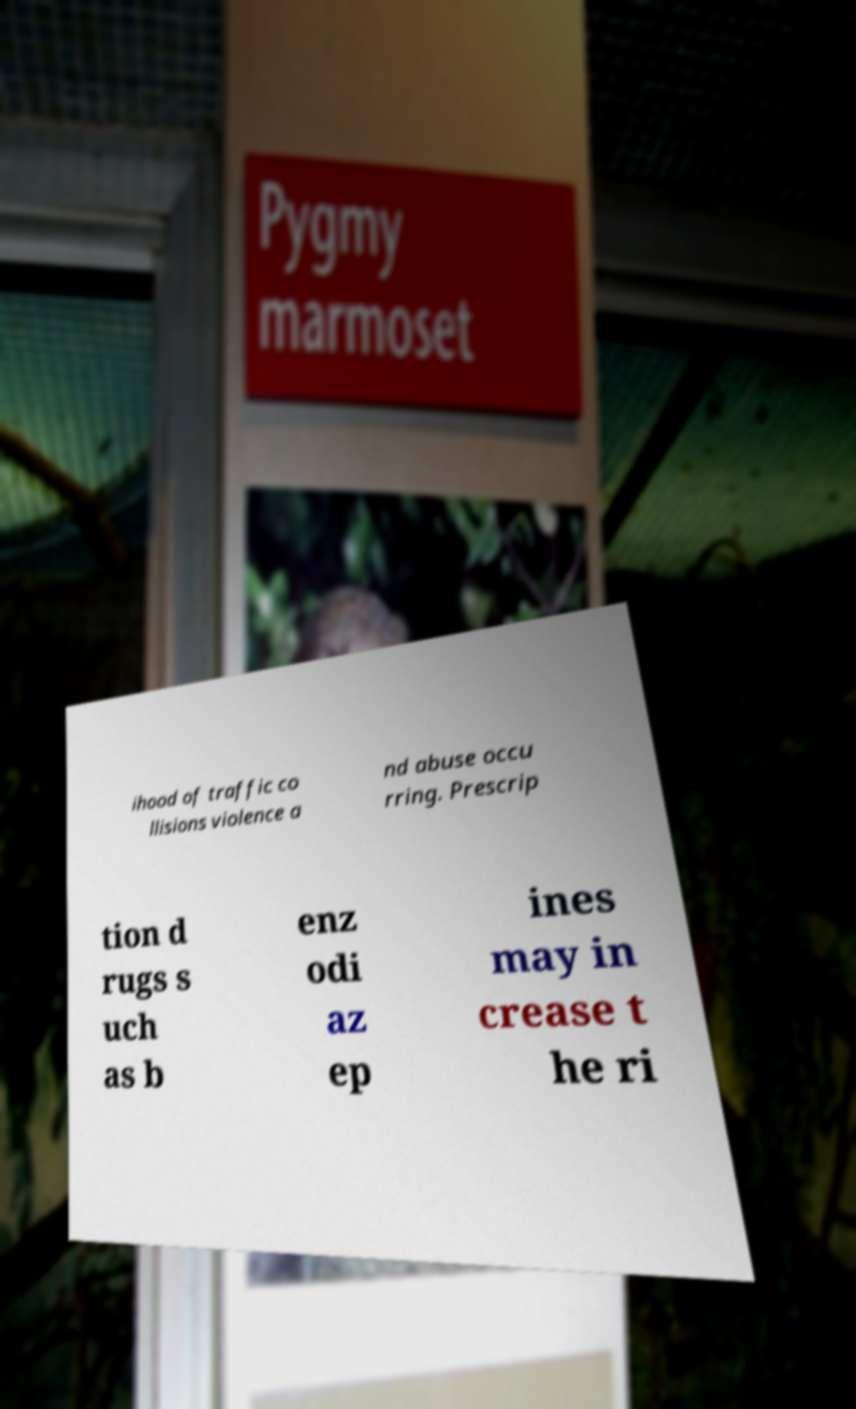Could you extract and type out the text from this image? ihood of traffic co llisions violence a nd abuse occu rring. Prescrip tion d rugs s uch as b enz odi az ep ines may in crease t he ri 